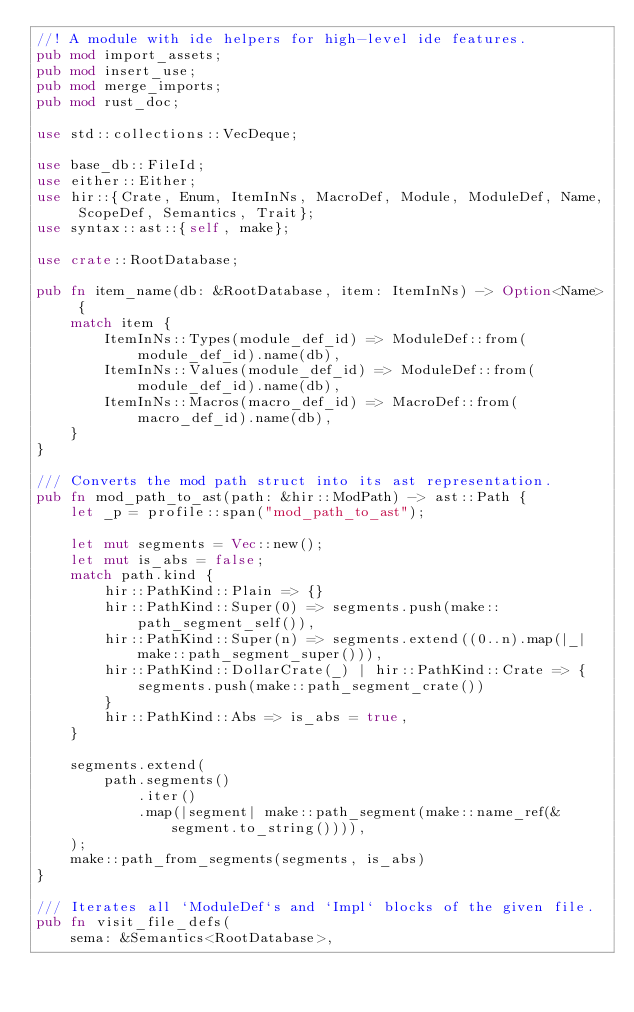<code> <loc_0><loc_0><loc_500><loc_500><_Rust_>//! A module with ide helpers for high-level ide features.
pub mod import_assets;
pub mod insert_use;
pub mod merge_imports;
pub mod rust_doc;

use std::collections::VecDeque;

use base_db::FileId;
use either::Either;
use hir::{Crate, Enum, ItemInNs, MacroDef, Module, ModuleDef, Name, ScopeDef, Semantics, Trait};
use syntax::ast::{self, make};

use crate::RootDatabase;

pub fn item_name(db: &RootDatabase, item: ItemInNs) -> Option<Name> {
    match item {
        ItemInNs::Types(module_def_id) => ModuleDef::from(module_def_id).name(db),
        ItemInNs::Values(module_def_id) => ModuleDef::from(module_def_id).name(db),
        ItemInNs::Macros(macro_def_id) => MacroDef::from(macro_def_id).name(db),
    }
}

/// Converts the mod path struct into its ast representation.
pub fn mod_path_to_ast(path: &hir::ModPath) -> ast::Path {
    let _p = profile::span("mod_path_to_ast");

    let mut segments = Vec::new();
    let mut is_abs = false;
    match path.kind {
        hir::PathKind::Plain => {}
        hir::PathKind::Super(0) => segments.push(make::path_segment_self()),
        hir::PathKind::Super(n) => segments.extend((0..n).map(|_| make::path_segment_super())),
        hir::PathKind::DollarCrate(_) | hir::PathKind::Crate => {
            segments.push(make::path_segment_crate())
        }
        hir::PathKind::Abs => is_abs = true,
    }

    segments.extend(
        path.segments()
            .iter()
            .map(|segment| make::path_segment(make::name_ref(&segment.to_string()))),
    );
    make::path_from_segments(segments, is_abs)
}

/// Iterates all `ModuleDef`s and `Impl` blocks of the given file.
pub fn visit_file_defs(
    sema: &Semantics<RootDatabase>,</code> 